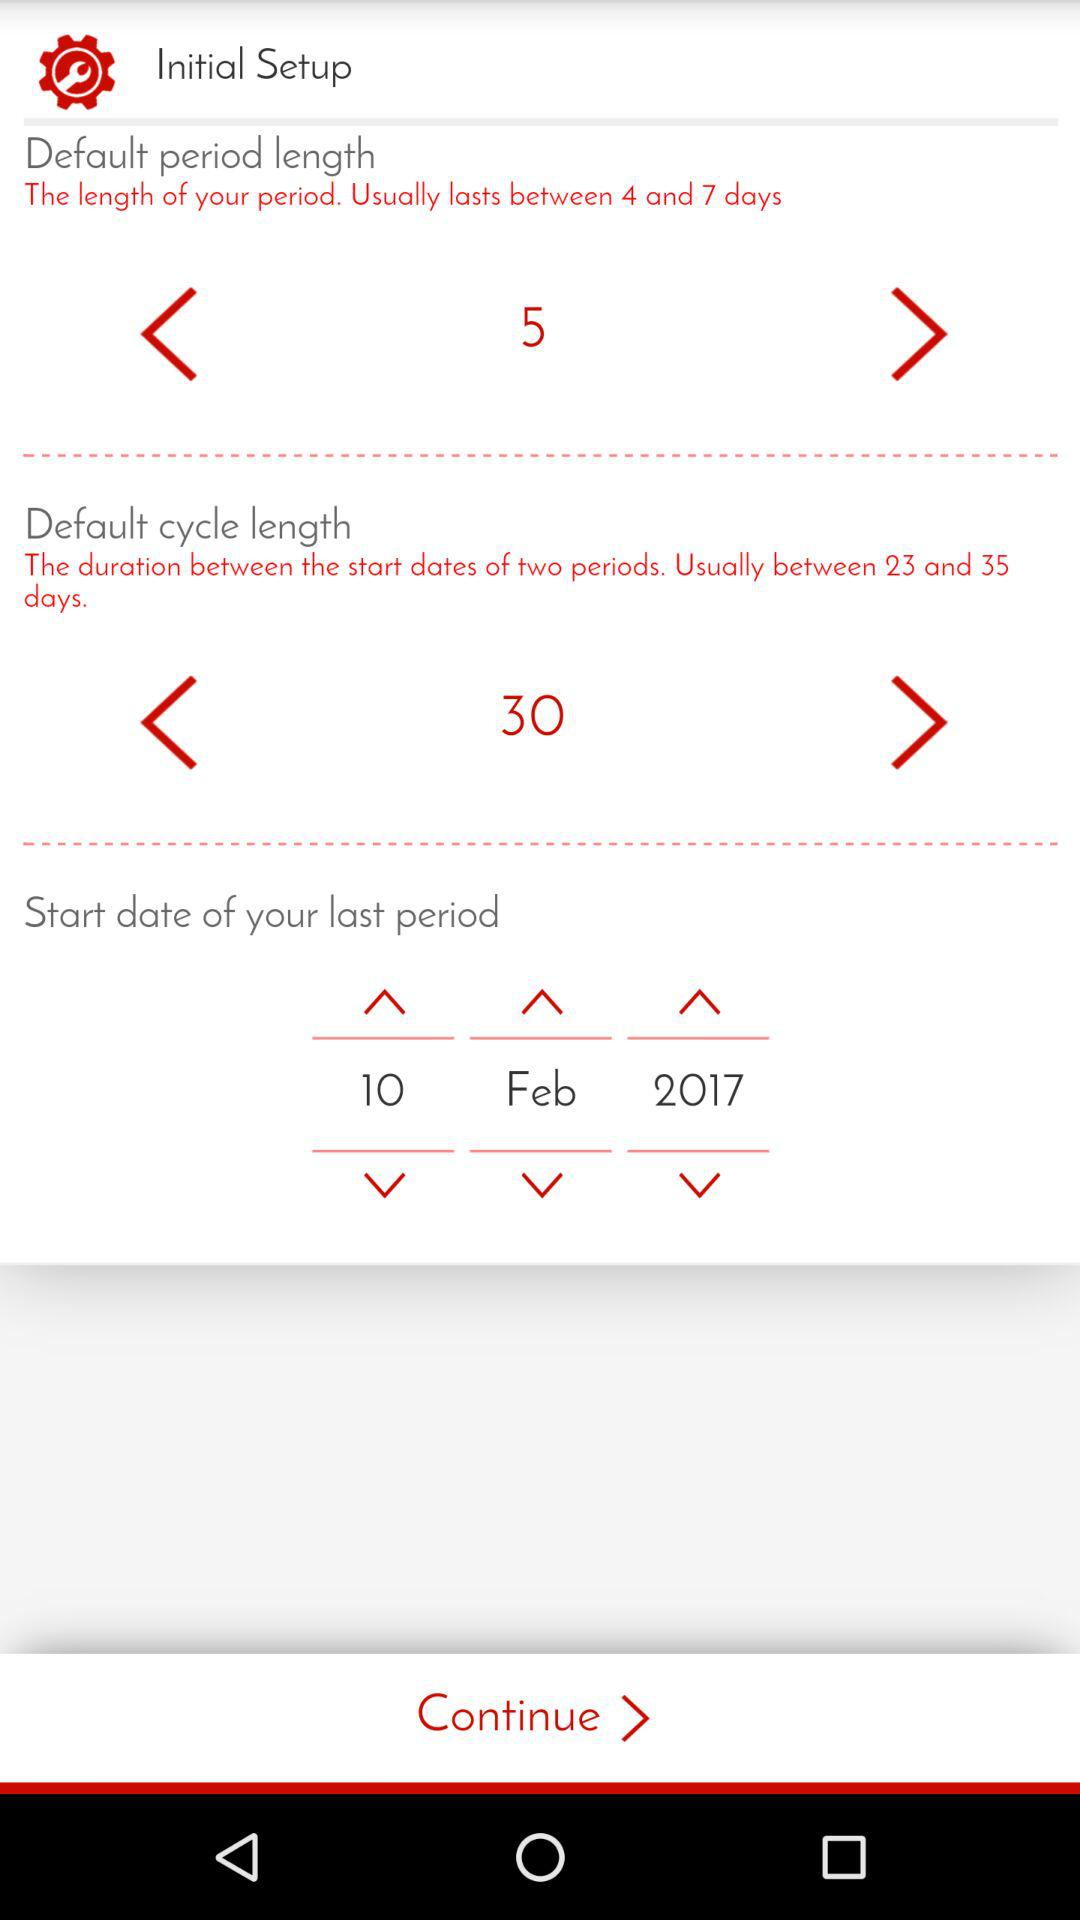What is the start date of the last period? The start date of the last period is February 10, 2017. 